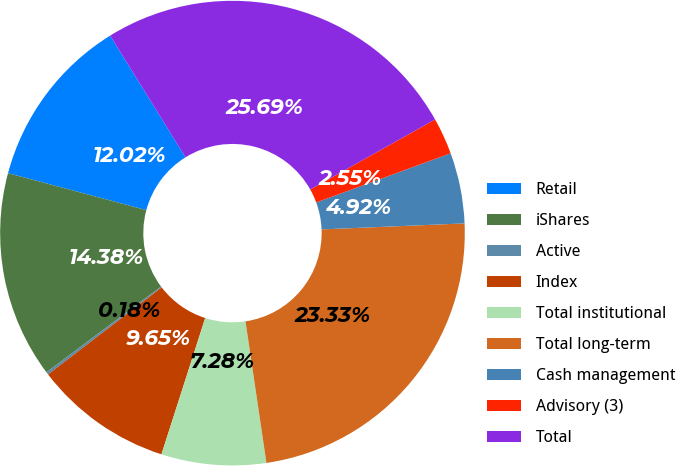Convert chart to OTSL. <chart><loc_0><loc_0><loc_500><loc_500><pie_chart><fcel>Retail<fcel>iShares<fcel>Active<fcel>Index<fcel>Total institutional<fcel>Total long-term<fcel>Cash management<fcel>Advisory (3)<fcel>Total<nl><fcel>12.02%<fcel>14.38%<fcel>0.18%<fcel>9.65%<fcel>7.28%<fcel>23.33%<fcel>4.92%<fcel>2.55%<fcel>25.69%<nl></chart> 